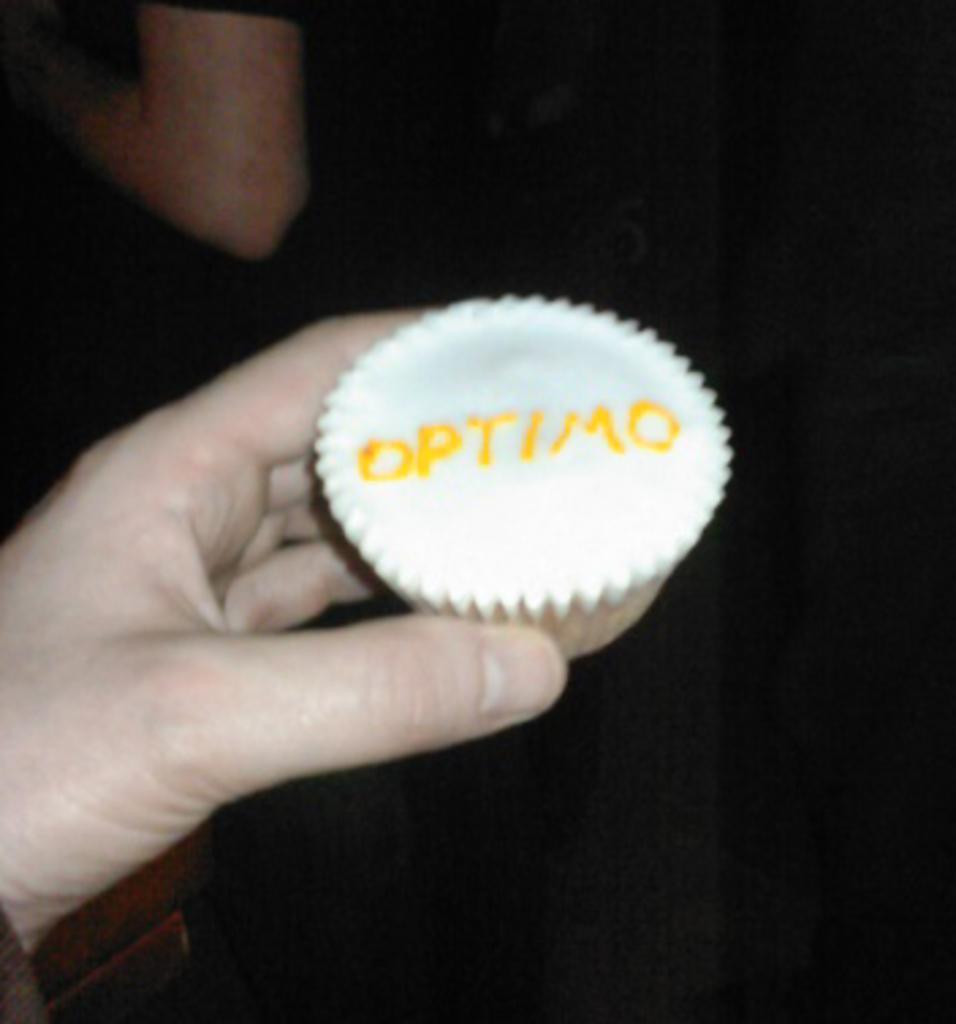Could you give a brief overview of what you see in this image? In this image we can see a person's hand with a cupcake. On the cupcake something is written. In the background it is dark. 